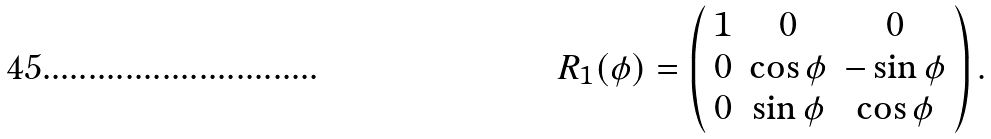<formula> <loc_0><loc_0><loc_500><loc_500>R _ { 1 } ( \phi ) = \left ( \begin{array} { c c c } 1 & 0 & 0 \\ 0 & \cos \phi & - \sin \phi \\ 0 & \sin \phi & \cos \phi \end{array} \right ) .</formula> 